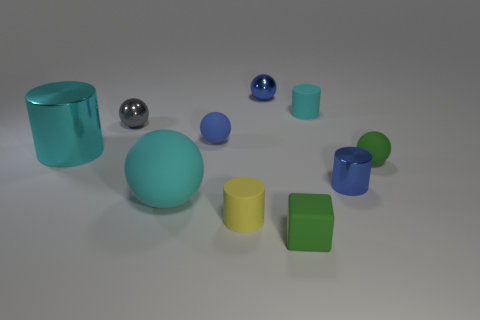Subtract 1 spheres. How many spheres are left? 4 Subtract all yellow balls. Subtract all gray cylinders. How many balls are left? 5 Subtract all cubes. How many objects are left? 9 Subtract 0 cyan blocks. How many objects are left? 10 Subtract all large cyan rubber balls. Subtract all shiny cylinders. How many objects are left? 7 Add 1 tiny objects. How many tiny objects are left? 9 Add 7 tiny green things. How many tiny green things exist? 9 